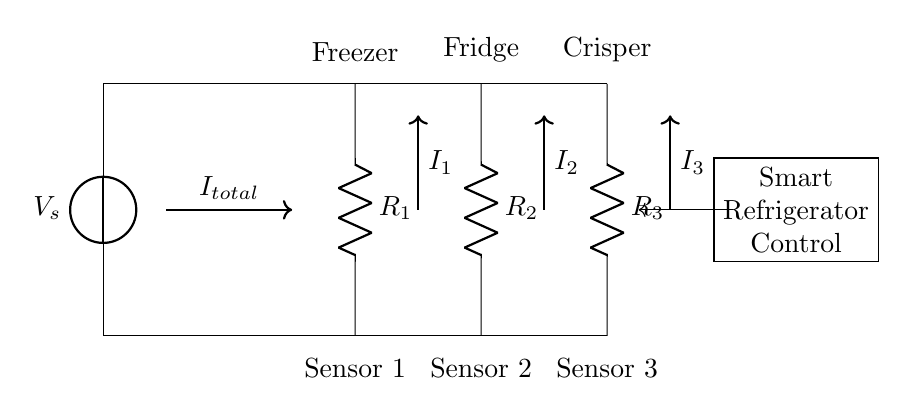What is the source voltage in this circuit? The source voltage is denoted as V_s at the voltage source in the circuit; it's the voltage supplied to the entire circuit.
Answer: V_s How many resistors are there in the circuit? The circuit diagram shows three resistors labeled as R_1, R_2, and R_3, which indicates that the total number of resistors is three.
Answer: 3 What is the role of the sensors in this circuit? The sensors are connected in parallel to the resistors, which represent temperature sensors located in different compartments of the smart refrigerator. This setup allows each sensor to measure the temperature simultaneously.
Answer: Temperature measurement What is the total current entering the parallel section? The total current entering the parallel section is represented as I_total, which is depicted in the diagram, indicating the total current flowing before it divides among the resistors.
Answer: I_total Which section has sensor 1? Sensor 1 corresponds to the resistor labeled R_1 in the diagram, located in the section marked as 'Freezer.'
Answer: Freezer What happens to the current through R_1 if its resistance increases? If the resistance of R_1 increases, according to the current divider rule, the current I_1 through that resistor will decrease, as higher resistance leads to lower current flow for a constant voltage.
Answer: Decreases How is the voltage across each sensor affected in this circuit? In a parallel circuit, the voltage across each resistor (and sensor) is the same and equal to the source voltage V_s. Therefore, the voltage across each sensor remains constant regardless of the current flowing through them.
Answer: Equal to V_s 